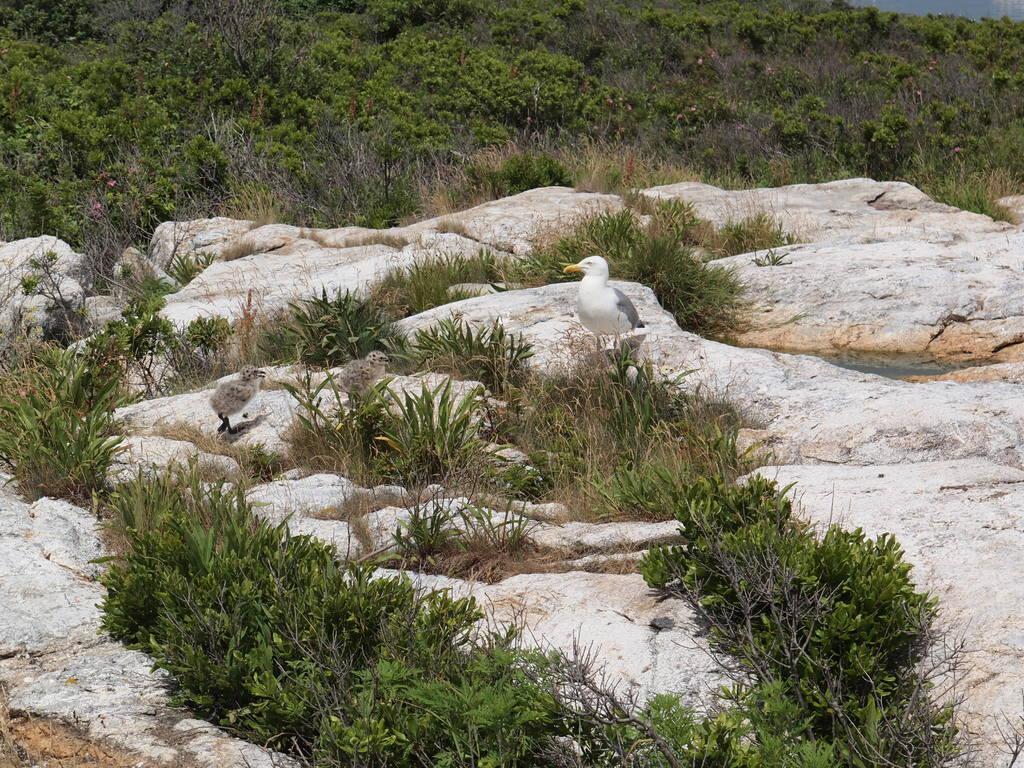Describe this image in one or two sentences. In the image we can see there are birds standing on the ground and there are plants on the rock. Behind there are lot of trees. 